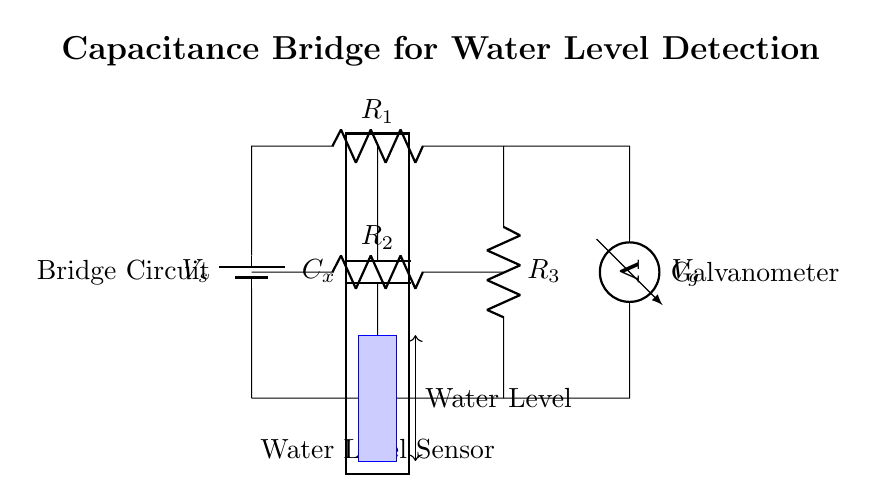What is the role of Cx in this circuit? Cx functions as a capacitor that changes its capacitance based on the water level detected, which helps balance the bridge circuit when the water level varies.
Answer: Capacitor What is the voltage source in this circuit? The voltage source is indicated as Vs in the diagram, which supplies the necessary electrical energy for the circuit operation.
Answer: Vs How many resistors are present in the bridge circuit? There are three resistors labeled as R1, R2, and R3 that are critical for creating the bridge configuration to ensure balanced conditions for measuring the capacitance.
Answer: Three What indicates the measured voltage in the circuit? The voltmeter, labeled as Vg in the circuit, measures the voltage difference across the bridge circuit, giving an indication when the circuit is balanced or unbalanced.
Answer: Voltmeter What does the blue rectangle represent in the circuit? The blue rectangle visually represents the area where water can be detected, showing the region that influences the water level sensor and, consequently, the capacitance of Cx.
Answer: Water level What is the significance of the bridge configuration in this circuit? The bridge configuration allows for precise measurement of small changes in capacitance due to varying water levels, which helps in distinguishing between different levels in the irrigation system.
Answer: Precision measurement How does the galvanometer contribute to the circuit? The galvanometer, indicated as Vg, detects any voltage imbalances in the bridge circuit, which may indicate changes in the capacitance related to the water level.
Answer: Detects imbalances 